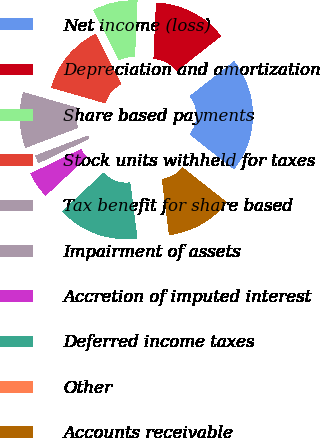<chart> <loc_0><loc_0><loc_500><loc_500><pie_chart><fcel>Net income (loss)<fcel>Depreciation and amortization<fcel>Share based payments<fcel>Stock units withheld for taxes<fcel>Tax benefit for share based<fcel>Impairment of assets<fcel>Accretion of imputed interest<fcel>Deferred income taxes<fcel>Other<fcel>Accounts receivable<nl><fcel>21.23%<fcel>13.7%<fcel>8.22%<fcel>13.01%<fcel>10.27%<fcel>1.37%<fcel>4.8%<fcel>15.07%<fcel>0.0%<fcel>12.33%<nl></chart> 